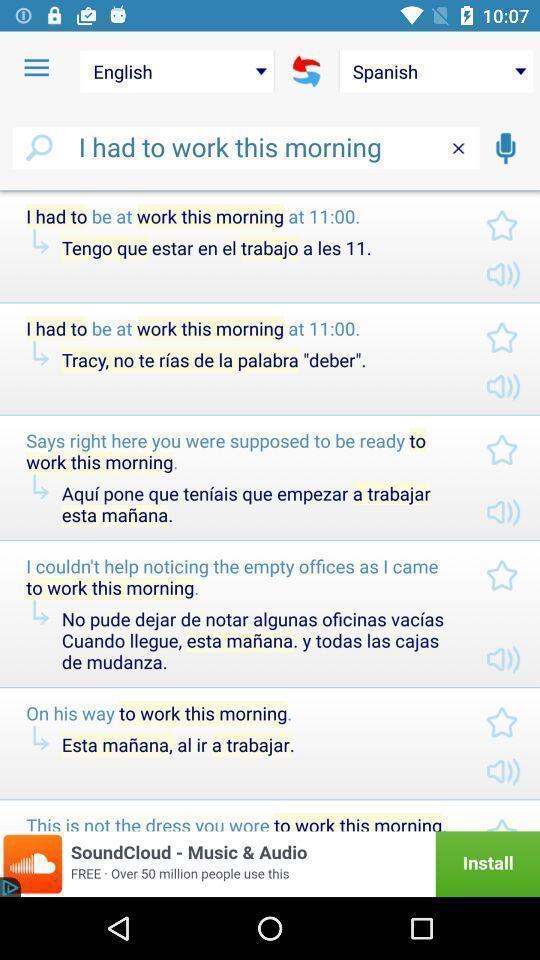Tell me what you see in this picture. Page that displaying language translator application. 